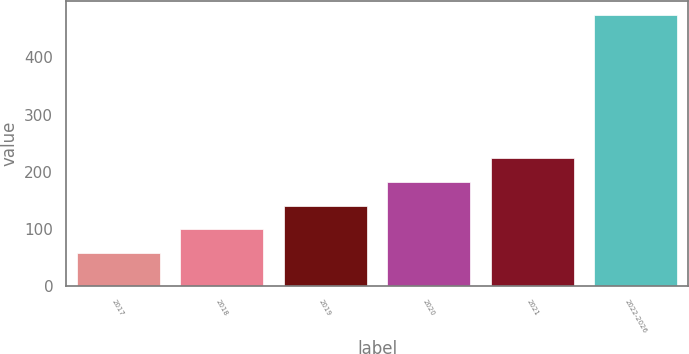<chart> <loc_0><loc_0><loc_500><loc_500><bar_chart><fcel>2017<fcel>2018<fcel>2019<fcel>2020<fcel>2021<fcel>2022-2026<nl><fcel>57<fcel>98.8<fcel>140.6<fcel>182.4<fcel>224.2<fcel>475<nl></chart> 